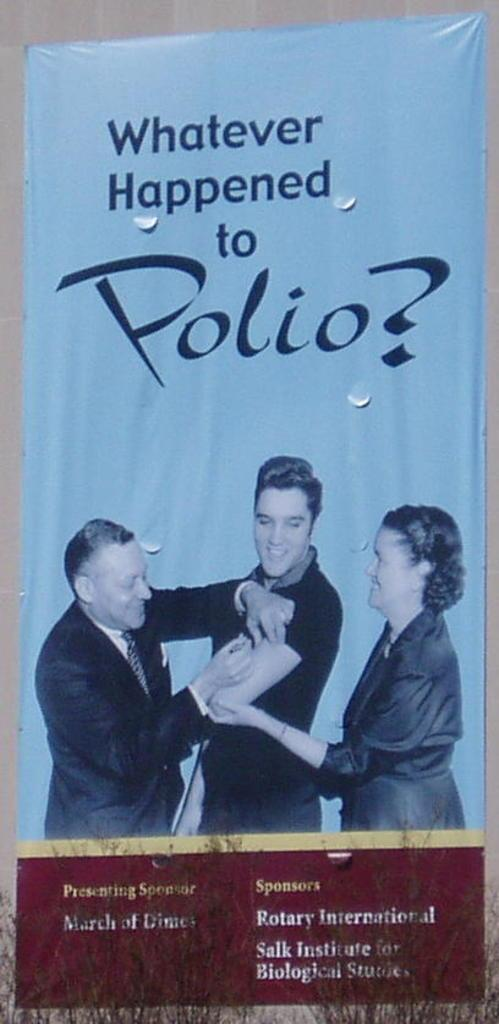Provide a one-sentence caption for the provided image. A poster of Elvis Presley getting a Polio Vaccine. 